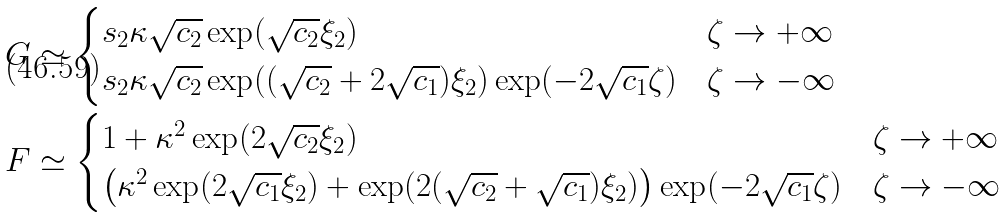<formula> <loc_0><loc_0><loc_500><loc_500>& G \simeq \begin{cases} s _ { 2 } \kappa \sqrt { c _ { 2 } } \exp ( \sqrt { c _ { 2 } } \xi _ { 2 } ) & \zeta \rightarrow + \infty \\ s _ { 2 } \kappa \sqrt { c _ { 2 } } \exp ( ( \sqrt { c _ { 2 } } + 2 \sqrt { c _ { 1 } } ) \xi _ { 2 } ) \exp ( - 2 \sqrt { c _ { 1 } } \zeta ) & \zeta \rightarrow - \infty \end{cases} \\ & F \simeq \begin{cases} 1 + \kappa ^ { 2 } \exp ( 2 \sqrt { c _ { 2 } } \xi _ { 2 } ) & \zeta \rightarrow + \infty \\ \left ( \kappa ^ { 2 } \exp ( 2 \sqrt { c _ { 1 } } \xi _ { 2 } ) + \exp ( 2 ( \sqrt { c _ { 2 } } + \sqrt { c _ { 1 } } ) \xi _ { 2 } ) \right ) \exp ( - 2 \sqrt { c _ { 1 } } \zeta ) & \zeta \rightarrow - \infty \end{cases}</formula> 